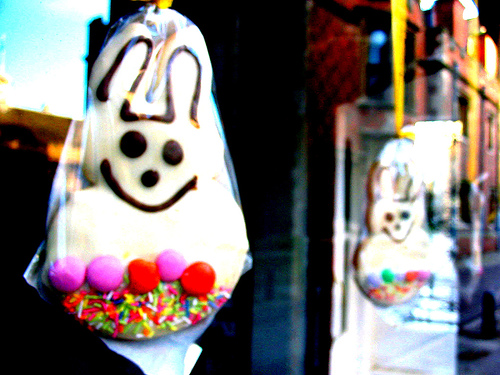<image>
Is the cookie in front of the window? Yes. The cookie is positioned in front of the window, appearing closer to the camera viewpoint. 